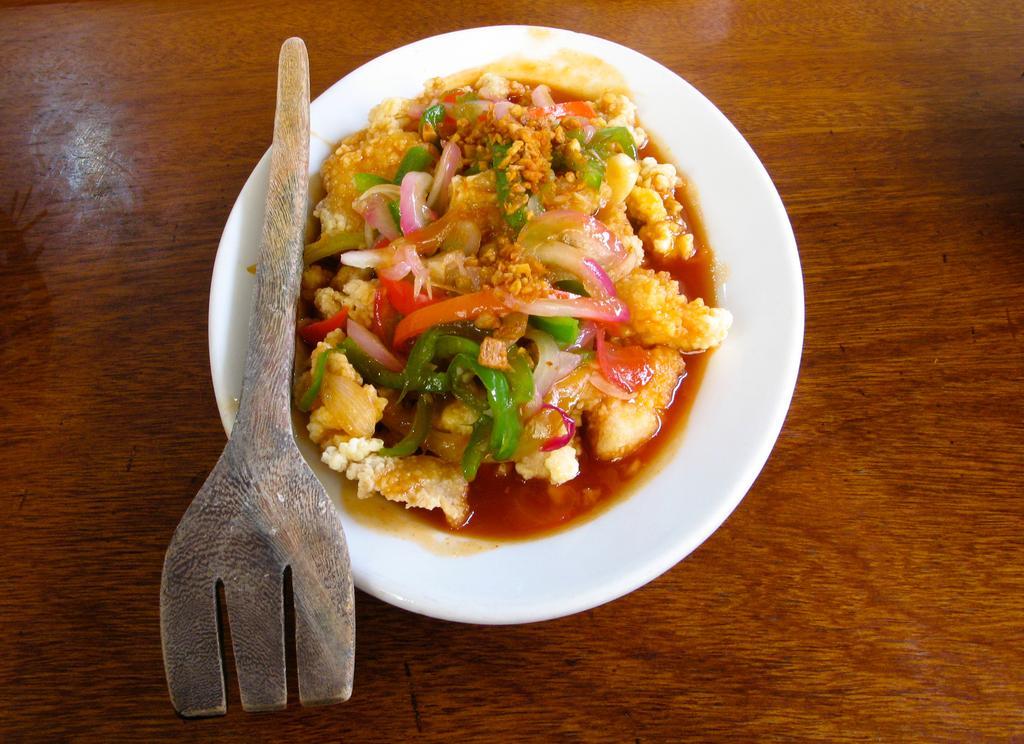Can you describe this image briefly? In the center of the image we can see a wooden object. On the wooden object, we can see one plate and one object. In the plate, we can see some food item. 